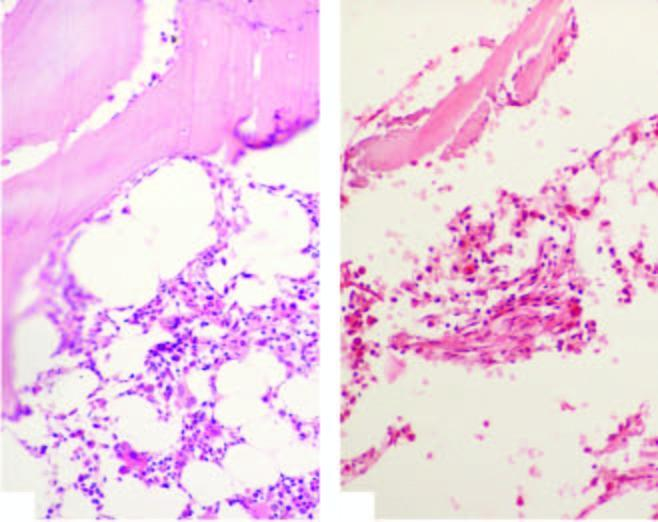s integration of viral genome into the host cell genome contrasted against normal cellular marrow?
Answer the question using a single word or phrase. No 